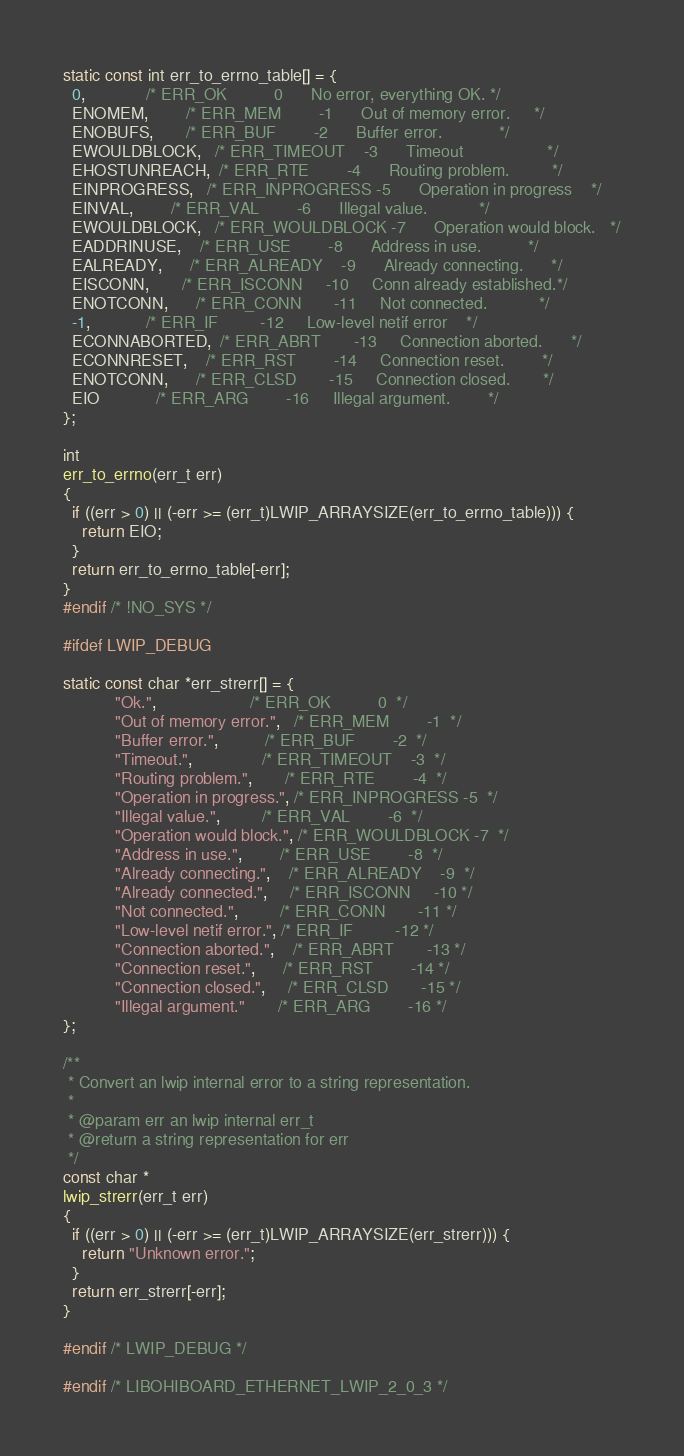<code> <loc_0><loc_0><loc_500><loc_500><_C_>static const int err_to_errno_table[] = {
  0,             /* ERR_OK          0      No error, everything OK. */
  ENOMEM,        /* ERR_MEM        -1      Out of memory error.     */
  ENOBUFS,       /* ERR_BUF        -2      Buffer error.            */
  EWOULDBLOCK,   /* ERR_TIMEOUT    -3      Timeout                  */
  EHOSTUNREACH,  /* ERR_RTE        -4      Routing problem.         */
  EINPROGRESS,   /* ERR_INPROGRESS -5      Operation in progress    */
  EINVAL,        /* ERR_VAL        -6      Illegal value.           */
  EWOULDBLOCK,   /* ERR_WOULDBLOCK -7      Operation would block.   */
  EADDRINUSE,    /* ERR_USE        -8      Address in use.          */
  EALREADY,      /* ERR_ALREADY    -9      Already connecting.      */
  EISCONN,       /* ERR_ISCONN     -10     Conn already established.*/
  ENOTCONN,      /* ERR_CONN       -11     Not connected.           */
  -1,            /* ERR_IF         -12     Low-level netif error    */
  ECONNABORTED,  /* ERR_ABRT       -13     Connection aborted.      */
  ECONNRESET,    /* ERR_RST        -14     Connection reset.        */
  ENOTCONN,      /* ERR_CLSD       -15     Connection closed.       */
  EIO            /* ERR_ARG        -16     Illegal argument.        */
};

int
err_to_errno(err_t err)
{
  if ((err > 0) || (-err >= (err_t)LWIP_ARRAYSIZE(err_to_errno_table))) {
    return EIO;
  }
  return err_to_errno_table[-err];
}
#endif /* !NO_SYS */

#ifdef LWIP_DEBUG

static const char *err_strerr[] = {
           "Ok.",                    /* ERR_OK          0  */
           "Out of memory error.",   /* ERR_MEM        -1  */
           "Buffer error.",          /* ERR_BUF        -2  */
           "Timeout.",               /* ERR_TIMEOUT    -3  */
           "Routing problem.",       /* ERR_RTE        -4  */
           "Operation in progress.", /* ERR_INPROGRESS -5  */
           "Illegal value.",         /* ERR_VAL        -6  */
           "Operation would block.", /* ERR_WOULDBLOCK -7  */
           "Address in use.",        /* ERR_USE        -8  */
           "Already connecting.",    /* ERR_ALREADY    -9  */
           "Already connected.",     /* ERR_ISCONN     -10 */
           "Not connected.",         /* ERR_CONN       -11 */
           "Low-level netif error.", /* ERR_IF         -12 */
           "Connection aborted.",    /* ERR_ABRT       -13 */
           "Connection reset.",      /* ERR_RST        -14 */
           "Connection closed.",     /* ERR_CLSD       -15 */
           "Illegal argument."       /* ERR_ARG        -16 */
};

/**
 * Convert an lwip internal error to a string representation.
 *
 * @param err an lwip internal err_t
 * @return a string representation for err
 */
const char *
lwip_strerr(err_t err)
{
  if ((err > 0) || (-err >= (err_t)LWIP_ARRAYSIZE(err_strerr))) {
    return "Unknown error.";
  }
  return err_strerr[-err];
}

#endif /* LWIP_DEBUG */

#endif /* LIBOHIBOARD_ETHERNET_LWIP_2_0_3 */
</code> 